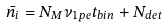<formula> <loc_0><loc_0><loc_500><loc_500>\bar { n _ { i } } = N _ { M } \nu _ { 1 p e } t _ { b i n } + N _ { d e t }</formula> 